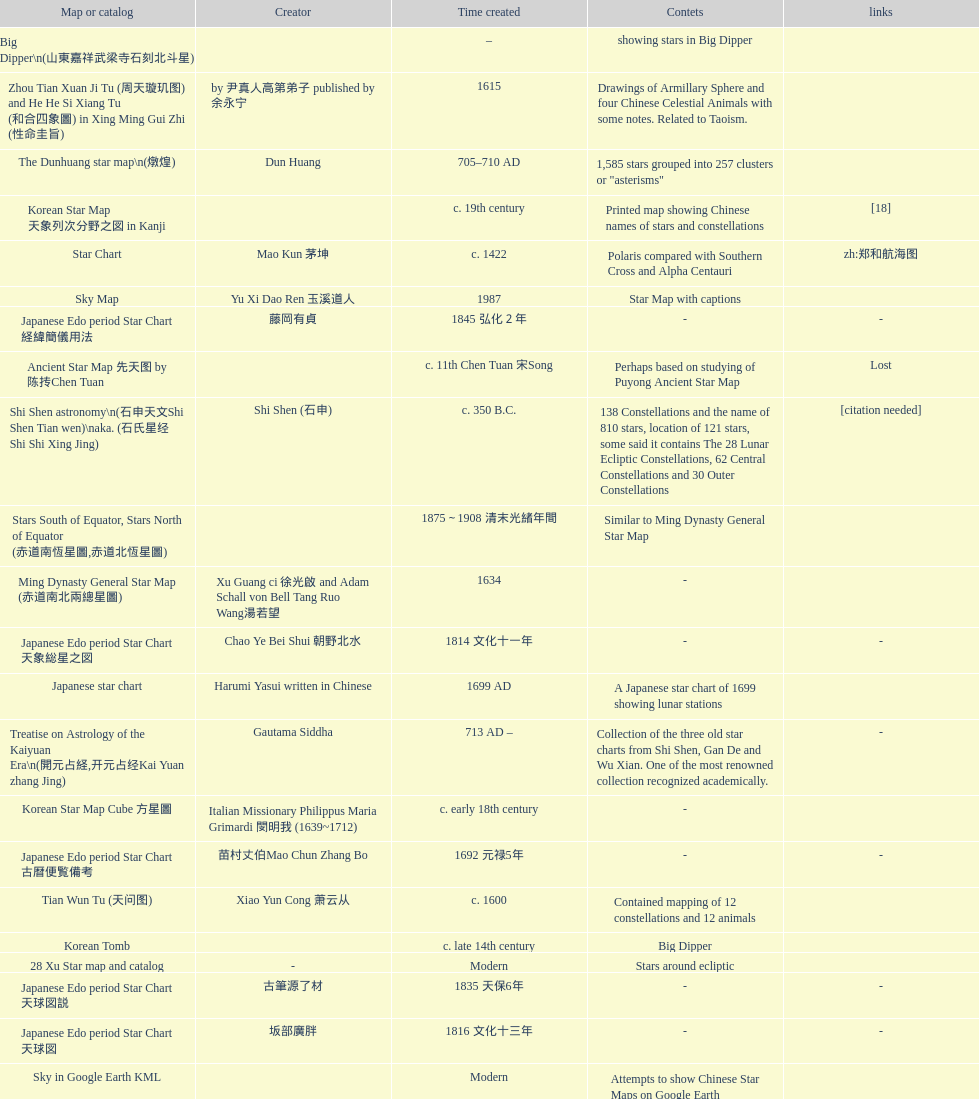What is the difference between the five star prediction device's date of creation and the han comet diagrams' date of creation? 25 years. Would you mind parsing the complete table? {'header': ['Map or catalog', 'Creator', 'Time created', 'Contets', 'links'], 'rows': [['Big Dipper\\n(山東嘉祥武梁寺石刻北斗星)', '', '–', 'showing stars in Big Dipper', ''], ['Zhou Tian Xuan Ji Tu (周天璇玑图) and He He Si Xiang Tu (和合四象圖) in Xing Ming Gui Zhi (性命圭旨)', 'by 尹真人高第弟子 published by 余永宁', '1615', 'Drawings of Armillary Sphere and four Chinese Celestial Animals with some notes. Related to Taoism.', ''], ['The Dunhuang star map\\n(燉煌)', 'Dun Huang', '705–710 AD', '1,585 stars grouped into 257 clusters or "asterisms"', ''], ['Korean Star Map 天象列次分野之図 in Kanji', '', 'c. 19th century', 'Printed map showing Chinese names of stars and constellations', '[18]'], ['Star Chart', 'Mao Kun 茅坤', 'c. 1422', 'Polaris compared with Southern Cross and Alpha Centauri', 'zh:郑和航海图'], ['Sky Map', 'Yu Xi Dao Ren 玉溪道人', '1987', 'Star Map with captions', ''], ['Japanese Edo period Star Chart 経緯簡儀用法', '藤岡有貞', '1845 弘化２年', '-', '-'], ['Ancient Star Map 先天图 by 陈抟Chen Tuan', '', 'c. 11th Chen Tuan 宋Song', 'Perhaps based on studying of Puyong Ancient Star Map', 'Lost'], ['Shi Shen astronomy\\n(石申天文Shi Shen Tian wen)\\naka. (石氏星经 Shi Shi Xing Jing)', 'Shi Shen (石申)', 'c. 350 B.C.', '138 Constellations and the name of 810 stars, location of 121 stars, some said it contains The 28 Lunar Ecliptic Constellations, 62 Central Constellations and 30 Outer Constellations', '[citation needed]'], ['Stars South of Equator, Stars North of Equator (赤道南恆星圖,赤道北恆星圖)', '', '1875～1908 清末光緒年間', 'Similar to Ming Dynasty General Star Map', ''], ['Ming Dynasty General Star Map (赤道南北兩總星圖)', 'Xu Guang ci 徐光啟 and Adam Schall von Bell Tang Ruo Wang湯若望', '1634', '-', ''], ['Japanese Edo period Star Chart 天象総星之図', 'Chao Ye Bei Shui 朝野北水', '1814 文化十一年', '-', '-'], ['Japanese star chart', 'Harumi Yasui written in Chinese', '1699 AD', 'A Japanese star chart of 1699 showing lunar stations', ''], ['Treatise on Astrology of the Kaiyuan Era\\n(開元占経,开元占经Kai Yuan zhang Jing)', 'Gautama Siddha', '713 AD –', 'Collection of the three old star charts from Shi Shen, Gan De and Wu Xian. One of the most renowned collection recognized academically.', '-'], ['Korean Star Map Cube 方星圖', 'Italian Missionary Philippus Maria Grimardi 閔明我 (1639~1712)', 'c. early 18th century', '-', ''], ['Japanese Edo period Star Chart 古暦便覧備考', '苗村丈伯Mao Chun Zhang Bo', '1692 元禄5年', '-', '-'], ['Tian Wun Tu (天问图)', 'Xiao Yun Cong 萧云从', 'c. 1600', 'Contained mapping of 12 constellations and 12 animals', ''], ['Korean Tomb', '', 'c. late 14th century', 'Big Dipper', ''], ['28 Xu Star map and catalog', '-', 'Modern', 'Stars around ecliptic', ''], ['Japanese Edo period Star Chart 天球図説', '古筆源了材', '1835 天保6年', '-', '-'], ['Japanese Edo period Star Chart 天球図', '坂部廣胖', '1816 文化十三年', '-', '-'], ['Sky in Google Earth KML', '', 'Modern', 'Attempts to show Chinese Star Maps on Google Earth', ''], ['Japanese Edo period Star Chart', '鈴木世孝', '1824 文政七年', '-', '-'], ['Japanese Edo period Star Chart 新制天球星象記', '田中政均', '1815 文化十二年', '-', '-'], ['Equatorial Armillary Sphere\\n(赤道式渾儀)', 'Luo Xiahong (落下閎)', '104 BC 西漢武帝時', 'lost', '[citation needed]'], ['Korean Star Chart 渾天図', '朴?', '-', '-', '-'], ['AEEA Star maps', '', 'Modern', 'Good reconstruction and explanation of Chinese constellations', ''], ['Song Dynasty Bronze Armillary Sphere 北宋天文院黄道渾儀', 'Shu Yijian 舒易簡, Yu Yuan 于渊, Zhou Cong 周琮', '宋皇祐年中', 'Similar to the Armillary by Tang Dynasty Liang Lingzan 梁令瓚 and Yi Xing 一行', '-'], ['Korean Star Map Stone', '', 'c. 17th century', '-', ''], ['Hun Tian Yi Tong Xing Xiang Quan Tu, Suzhou Star Chart (蘇州石刻天文圖),淳祐天文図', 'Huang Shang (黃裳)', 'created in 1193, etched to stone in 1247 by Wang Zhi Yuan 王致遠', '1434 Stars grouped into 280 Asterisms in Northern Sky map', ''], ['Simplified Chinese and Western Star Map', 'Yi Shi Tong 伊世同', 'Aug. 1963', 'Star Map showing Chinese Xingquan and Western Constellation boundaries', ''], ['The Celestial Globe 清康熙 天體儀', 'Ferdinand Verbiest 南懷仁', '1673', '1876 stars grouped into 282 asterisms', ''], ['Japanese Star Chart 格子月進図', '', '1324', 'Similar to Su Song Star Chart, original burned in air raids during World War II, only pictures left. Reprinted in 1984 by 佐佐木英治', ''], ['Japanese Edo period Star Chart 分野星図', '高塚福昌, 阿部比輔, 上条景弘', '1849 嘉永2年', '-', '-'], ['Five Star Prediction Device\\n(安徽阜陽五星候占儀)', '', '168 BC', 'Also an Equatorial Device', '[citation needed]'], ['Northern Wei Grave Dome Star Map\\n(河南洛陽北魏墓頂星圖)', '', '526 AD 北魏孝昌二年', 'about 300 stars, including the Big Dipper, some stars are linked by straight lines to form constellation. The Milky Way is also shown.', ''], ['Han Grave Mural Star Chart\\n(洛阳西汉墓壁画)\\n(星象图Xing Xiang Tu)', '', 'c. 1st century', 'Sun, Moon and ten other star charts', ''], ['Whole Sky Star Maps\\n(全天星圖Quan Tian Xing Tu)', 'Chen Zhuo (陳卓)', 'c. 270 AD 西晉初Xi Jin Chu', 'A Unified Constellation System. Star maps containing 1464 stars in 284 Constellations, written astrology text', '-'], ['Korean star map in stone', '', '1687', '-', ''], ['Song Dynasty Water-powered Planetarium 宋代 水运仪象台', 'Su Song 蘇頌 and Han Gonglian 韩公廉', 'c. 11th century', '-', ''], ['Han Comet Diagrams\\n(湖南長沙馬王堆漢墓帛書)\\n(彗星圖Meng xing Tu)', '', '193 BC', 'Different 29 different types of comets, also record and prediction of positions of Jupiter, Saturn, and Venus during 246–177 B.C.', ''], ['Kitora Kofun 法隆寺FaLong Si\u3000キトラ古墳 in Japan', '', 'c. late 7th century – early 8th century', 'Detailed whole sky map', ''], ['Japanese Edo period Star Chart 天象列次之図 based on 天象列次分野之図 from Korean', 'Harumi Shibukawa 渋川春海Bu Chuan Chun Mei(保井春海Bao Jing Chun Mei)', '1670 寛文十年', '-', ''], ['Wu Xian Star Map\\n(商巫咸星圖Shang wu Jian xing Tu)', 'Wu Xian', 'c. 1000 BC', 'Contained 44 Central and Outer constellations totalling 141 stars', '[citation needed]'], ['Star Chart in a Dao Temple 玉皇山道觀星圖', '', '1940 AD', '-', '-'], ['Chanshu Star Chart (明常熟石刻天文圖)', '', '1506', 'Based on Suzhou Star Chart, Northern Sky observed at 36.8 degrees North Latitude, 1466 stars grouped into 284 asterism', '-'], ['Picture depicted Song Dynasty fictional astronomer (呉用 Wu Yong) with a Celestial Globe (天體儀)', 'Japanese painter', '1675', 'showing top portion of a Celestial Globe', 'File:Chinese astronomer 1675.jpg'], ['Ming Ancient Star Chart 北京隆福寺(古星圖)', '', 'c. 1453 明代', '1420 Stars, possibly based on old star maps from Tang Dynasty', ''], ['Korean Map of Heaven and Earth 天地圖', '', 'c. 19th century', '28 Constellations and geographic map', ''], ['Song Dynasty Armillary Sphere 北宋簡化渾儀', 'Shen Kuo 沈括 and Huangfu Yu 皇甫愈', '1089 AD 熙寧七年', 'Simplied version of Tang Dynasty Device, removed the rarely used moon orbit.', '-'], ['Star Chart 清蒙文石刻(欽天監繪製天文圖) in Mongolia', '', '1727–1732 AD', '1550 stars grouped into 270 starisms.', ''], ['North Sky Map 清嘉庆年间Huang Dao Zhong Xi He Tu(黄道中西合图)', 'Xu Choujun 徐朝俊', '1807 AD', 'More than 1000 stars and the 28 consellation', ''], ['Korean Complete map of the celestial sphere (渾天全圖)', '', 'c. 19th century', '-', ''], ['天象列次分野之図(Cheonsang Yeolcha Bunyajido)', '', '1395', 'Korean versions of Star Map in Stone. It was made in Chosun Dynasty and the constellation names were written in Chinese letter. The constellations as this was found in Japanese later. Contained 1,464 stars.', ''], ['Japanese Edo period Star Chart 天文図解', '井口常範', '1689 元禄2年', '-', '-'], ['Japanese Edo period Star Chart 天文分野之図', 'Harumi Shibukawa 渋川春海BuJingChun Mei (保井春海Bao JingChunMei)', '1677 延宝五年', '-', ''], ['Japanese Star Chart', '伊能忠誨', 'c. 19th century', '-', '-'], ['Fuxi 64 gua 28 xu wood carving 天水市卦台山伏羲六十四卦二十八宿全图', '', 'modern', '-', '-'], ['修真內外火侯全圖 Huo Hou Tu', 'Xi Chun Sheng Chong Hui\\p2005 redrawn, original unknown', 'illustrations of Milkyway and star maps, Chinese constellations in Taoism view', '', ''], ['Japanese Edo period Star Chart 天経或問註解図巻\u3000下', '入江脩敬Ru Jiang YOu Jing', '1750 寛延3年', '-', '-'], ['Collection of printed star maps', '', 'Modern', '-', ''], ['Japanese Edo period Star Chart 方円星図,方圓星図 and 増補分度星図方図', '石坂常堅', '1826b文政9年', '-', '-'], ['Warring States Period grave lacquer box\\n(戰國初年湖北隨縣擂鼓墩曾侯乙墓漆箱)', '', 'c. 5th century BC', 'Indicated location of Big Dipper and 28 Constellations by characters', ''], ['Japanese Edo period Star Chart 星図歩天歌', '小島好謙 and 鈴木世孝', '1824 文政七年', '-', '-'], ['Star maps', '', 'Recent', 'Chinese 28 Constellation with Chinese and Japanese captions', ''], ['Star map', '', 'Recent', 'An attempt by a Japanese to reconstruct the night sky for a historical event around 235 AD 秋風五丈原', ''], ['Japanese Star Chart 天体図', '三浦梅園', '-', '-', '-'], ['Stars map (恒星赤道経緯度図)stored in Japan', '', '1844 道光24年 or 1848', '-', '-'], ['HNSKY Korean/Chinese Supplement', 'Jeong, Tae-Min(jtm71)/Chuang_Siau_Chin', 'Modern', 'Korean supplement is based on CheonSangYeulChaBunYaZiDo (B.C.100 ~ A.D.100)', ''], ['Japanese Star Chart 改正天文図説', '', 'unknown', 'Included stars from Harumi Shibukawa', ''], ['Korean Star maps: Star Map South to the Ecliptic 黃道南恒星圖 and Star Map South to the Ecliptic 黃道北恒星圖', '', 'c. 19th century', 'Perhaps influenced by Adam Schall von Bell Tang Ruo wang 湯若望 (1591–1666) and P. Ignatius Koegler 戴進賢 (1680–1748)', ''], ['Ming Dynasty Planetarium Machine (渾象 Hui Xiang)', '', 'c. 17th century', 'Ecliptic, Equator, and dividers of 28 constellation', ''], ['Japanese Edo period Star Chart 昊天図説詳解', '佐藤祐之', '1824 文政七年', '-', '-'], ['Liao Dynasty Tomb Dome Star Map 遼宣化张世卿墓頂星圖', '', '1116 AD 遼天庆六年', 'shown both the Chinese 28 Constellation encircled by Babylonian Zodiac', ''], ['Picture of Fuxi and Nüwa 新疆阿斯達那唐墓伏羲Fu Xi 女媧NV Wa像Xiang', '', 'Tang Dynasty', 'Picture of Fuxi and Nuwa together with some constellations', 'Image:Nuva fuxi.gif'], ['Korean Book of New Song of the Sky Pacer 新法步天歌', '李俊養', '1862', 'Star maps and a revised version of the Song of Sky Pacer', ''], ['Astronomic star observation\\n(天文星占Tian Wen xing zhan)', 'Gan De (甘德)', '475-221 B.C.', 'Contained 75 Central Constellation and 42 Outer Constellations, some said 510 stars in 18 Constellations', '[citation needed]'], ['Ming Dynasty diagrams of Armillary spheres and Celestial Globes', 'Xu Guang ci 徐光啟', 'c. 1699', '-', ''], ['Prajvalonisa Vjrabhairava Padvinasa-sri-dharani Scroll found in Japan 熾盛光佛頂大威德銷災吉祥陀羅尼經卷首扉畫', '', '972 AD 北宋開寶五年', 'Chinese 28 Constellations and Western Zodiac', '-'], ['Japanese Star Chart 瀧谷寺 天之図', '', 'c. 14th or 15th centuries 室町中期以前', '-', ''], ['Sky Map\\n(浑天图)\\nand\\nHun Tian Yi Shuo\\n(浑天仪说)', 'Lu Ji (陆绩)', '187–219 AD 三国', '-', '-'], ['Copper Plate Star Map stored in Korea', '', '1652 順治九年shun zi jiu nian', '-', ''], ['Korean Star Maps, North and South to the Eclliptic 黃道南北恒星圖', '', '1742', '-', ''], ['Jingban Tianwen Quantu by Ma Junliang 马俊良', '', '1780–90 AD', 'mapping nations to the sky', ''], ['Japanese Star Map 天象一覧図 in Kanji', '桜田虎門', '1824 AD 文政７年', 'Printed map showing Chinese names of stars and constellations', ''], ['Equatorial Armillary Sphere\\n(渾儀Hun Xi)', 'Kong Ting (孔挺)', '323 AD 東晉 前趙光初六年', 'level being used in this kind of device', '-'], ['Korean Star Map', '', 'c. 19th century, late Choson Period', '-', ''], ['Water-powered Planetarium\\n(水力渾天儀)', 'Geng Xun (耿詢)', 'c. 7th century 隋初Sui Chu', '-', '-'], ['First Ecliptic Armillary Sphere\\n(黄道仪Huang Dao Yi)', 'Jia Kui 贾逵', '30–101 AD 东汉永元十五年', '-', '-'], ['Ceramic Ink Sink Cover', '', 'c. 17th century', 'Showing Big Dipper', ''], ['Turfan Tomb Star Mural\\n(新疆吐鲁番阿斯塔那天文壁画)', '', '250–799 AD 唐', '28 Constellations, Milkyway and Five Stars', ''], ['Tangut Khara-Khoto (The Black City) Star Map 西夏黑水城星圖', '', '940 AD', 'A typical Qian Lezhi Style Star Map', '-'], ['Stellarium Chinese and Korean Sky Culture', 'G.S.K. Lee; Jeong, Tae-Min(jtm71); Yu-Pu Wang (evanzxcv)', 'Modern', 'Major Xingguans and Star names', ''], ['Japanese Edo period Star Measuring Device 中星儀', '足立信順Zhu Li Xin Shun', '1824 文政七年', '-', '-'], ['M45 (伏羲星图Fuxixingtu)', '', 'c. 4000 B.C.', 'Found in a mural in a Neolithic Grave in Henan Puyang (河南濮陽西水坡新石器時代古墓) clam shells arranged in the shape of Big Dipper in the North (北斗Bei Dou) and below the foot, Tiger in the West and Azure Dragon in the East. Also showing Five Stars.', '[citation needed]'], ['Southern Dynasties Period Whole Sky Planetarium\\n(渾天象Hun Tian Xiang)', 'Qian Lezhi (錢樂之)', '443 AD 南朝劉宋元嘉年間', 'used red, black and white to differentiate stars from different star maps from Shi Shen, Gan De and Wu Xian 甘, 石, 巫三家星', '-'], ['Reproduction of an ancient device 璇璣玉衡', 'Dai Zhen 戴震', '1723–1777 AD', 'based on ancient record and his own interpretation', 'Could be similar to'], ['Japanese Star Chart 梅園星図', '高橋景保', '-', '-', ''], ['28 Constellations, big dipper and 4 symbols Star map', '', 'Modern', '-', ''], ['Korean Book of Stars 經星', '', 'c. 19th century', 'Several star maps', ''], ['Wikipedia Star maps', '', 'Modern', '-', 'zh:華蓋星'], ['Yuan Dynasty Simplified Armillary Sphere 元代簡儀', 'Guo Shou Jing 郭守敬', '1276–1279', 'Further simplied version of Song Dynasty Device', ''], ['Japanese Late Edo period Star Chart 天文図屏風', '遠藤盛俊', 'late Edo Period 江戸時代後期', '-', '-'], ['Japanese Edo period Star Chart 天象管鈔 天体図 (天文星象図解)', '長久保赤水', '1824 文政七年', '-', ''], ['Lingtai Miyuan\\n(靈台秘苑)', 'Yu Jicai (庾季才) and Zhou Fen (周墳)', '604 AD 隋Sui', 'incorporated star maps from different sources', '-'], ['Qing Dynasty Star Catalog (儀象考成,仪象考成)恒星表 and Star Map 黄道南北両星総図', 'Yun Lu 允禄 and Ignatius Kogler 戴进贤Dai Jin Xian 戴進賢, a German', 'Device made in 1744, book completed in 1757 清乾隆年间', '300 Constellations and 3083 Stars. Referenced Star Catalogue published by John Flamsteed', ''], ['The Chinese Sky during the Han Constellating Stars and Society', 'Sun Xiaochun and Jacob Kistemaker', '1997 AD', 'An attempt to recreate night sky seen by Chinese 2000 years ago', ''], ['Five Star Charts (新儀象法要)', 'Su Song 蘇頌', '1094 AD', '1464 stars grouped into 283 asterisms', 'Image:Su Song Star Map 1.JPG\\nImage:Su Song Star Map 2.JPG'], ['Japanese Edo period Star Chart 天文成象Tian Wen Cheng xiang', '(渋川昔尹She Chuan Xi Yin) (保井昔尹Bao Jing Xi Yin)', '1699 元禄十二年', 'including Stars from Wu Shien (44 Constellation, 144 stars) in yellow; Gan De (118 Constellations, 511 stars) in black; Shi Shen (138 Constellations, 810 stars) in red and Harumi Shibukawa (61 Constellations, 308 stars) in blue;', ''], ['Celestial Globe\\n(渾象)\\n(圓儀)', 'Geng Shouchang (耿壽昌)', '52 BC 甘露二年Gan Lu Er Ren', 'lost', '[citation needed]'], ['Song Dynasty Bronze Armillary Sphere 北宋至道銅渾儀', 'Han Xianfu 韓顯符', '1006 AD 宋道元年十二月', 'Similar to the Simplified Armillary by Kong Ting 孔挺, 晁崇 Chao Chong, 斛蘭 Hu Lan', '-'], ['First remark of a constellation in observation in Korean history', '', '49 BC 혁거세 거서간 9년', "The star 'Pae'(a kind of comet) appeared in the constellation Wang Rang", 'Samguk Sagi'], ['Ming Dynasty Star Map (渾蓋通憲圖說)', 'Matteo Ricci 利玛窦Li Ma Dou, recorded by Li Zhizao 李之藻', 'c. 1550', '-', ''], ['Tang Dynasty Indian Horoscope Chart\\n(梵天火羅九曜)', 'Yixing Priest 一行和尚 (张遂)\\pZhang Sui\\p683–727 AD', 'simple diagrams of the 28 Constellation', '', ''], ["Star Map in a woman's grave (江西德安 南宋周氏墓星相图)", '', '1127–1279 AD', 'Milky Way and 57 other stars.', ''], ['Korean Complete Star Map (渾天全圖)', '', 'c. 18th century', '-', ''], ["Korean King Sejong's Armillary sphere", '', '1433', '-', ''], ['Tang Dynasty Whole Sky Ecliptic Armillary Sphere\\n(渾天黃道儀)', 'Li Chunfeng 李淳風', '667 AD 貞觀七年', 'including Elliptic and Moon orbit, in addition to old equatorial design', '-'], ['Qing Dynasty Star Catalog (儀象考成續編)星表', '', '1844', 'Appendix to Yi Xian Kao Cheng, listed 3240 stars (added 163, removed 6)', ''], ['Star Chart 五代吳越文穆王前元瓘墓石刻星象圖', '', '941–960 AD', '-', ''], ['Han Dynasty Nanyang Stone Engraving\\n(河南南阳汉石刻画)\\n(行雨图Xing Yu Tu)', '', 'c. 1st century', 'Depicted five stars forming a cross', ''], ['Chinese Star map', 'John Reeves esq', '1819 AD', 'Printed map showing Chinese names of stars and constellations', ''], ['Star Map with illustrations for Xingguans', '坐井★观星Zuo Jing Guan Xing', 'Modern', 'illustrations for cylindrical and circular polar maps', ''], ['Korean Astronomy Book "Selected and Systematized Astronomy Notes" 天文類抄', '', '1623~1649', 'Contained some star maps', ''], ['Rock Star Chart 清代天文石', '', 'c. 18th century', 'A Star Chart and general Astronomy Text', ''], ['SinoSky Beta 2.0', '', '2002', 'A computer program capable of showing Chinese Xingguans alongside with western constellations, lists about 700 stars with Chinese names.', ''], ['Korean version of 28 Constellation 列宿圖', '', 'c. 19th century', '28 Constellations, some named differently from their Chinese counterparts', ''], ['Reproduced Hun Tian Yi\\n(浑天仪)\\nand wrote\\nHun Tian Xiang Shuo\\n(浑天象说)', 'Wang Fan 王蕃', '227–266 AD 三国', '-', '-'], ['Northern Wei Period Iron Armillary Sphere\\n(鐵渾儀)', 'Hu Lan (斛蘭)', 'Bei Wei\\plevel being used in this kind of device', '-', ''], ['Korean Star Map', '', 'c. 17th century', '-', ''], ['Tang Dynasty Armillary Sphere\\n(唐代渾儀Tang Dai Hun Xi)\\n(黃道遊儀Huang dao you xi)', 'Yixing Monk 一行和尚 (张遂)Zhang Sui and Liang Lingzan 梁令瓚', '683–727 AD', 'based on Han Dynasty Celestial Globe, recalibrated locations of 150 stars, determined that stars are moving', ''], ['Eastern Han Celestial Globe and star maps\\n(浑天仪)\\n(渾天儀圖注,浑天仪图注)\\n(靈憲,灵宪)', 'Zhang Heng (张衡)', '117 AD', '-', '-'], ['Japanese Edo period Illustration of a Star Measuring Device 平天儀図解', 'Yan Qiao Shan Bing Heng 岩橋善兵衛', '1802 Xiang He Er Nian 享和二年', '-', 'The device could be similar to'], ['Star Chart preserved in Japan based on a book from China 天経或問', 'You Zi liu 游子六', '1730 AD 江戸時代 享保15年', 'A Northern Sky Chart in Chinese', '']]} 